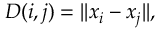<formula> <loc_0><loc_0><loc_500><loc_500>D ( i , j ) = | | x _ { i } - x _ { j } | | ,</formula> 